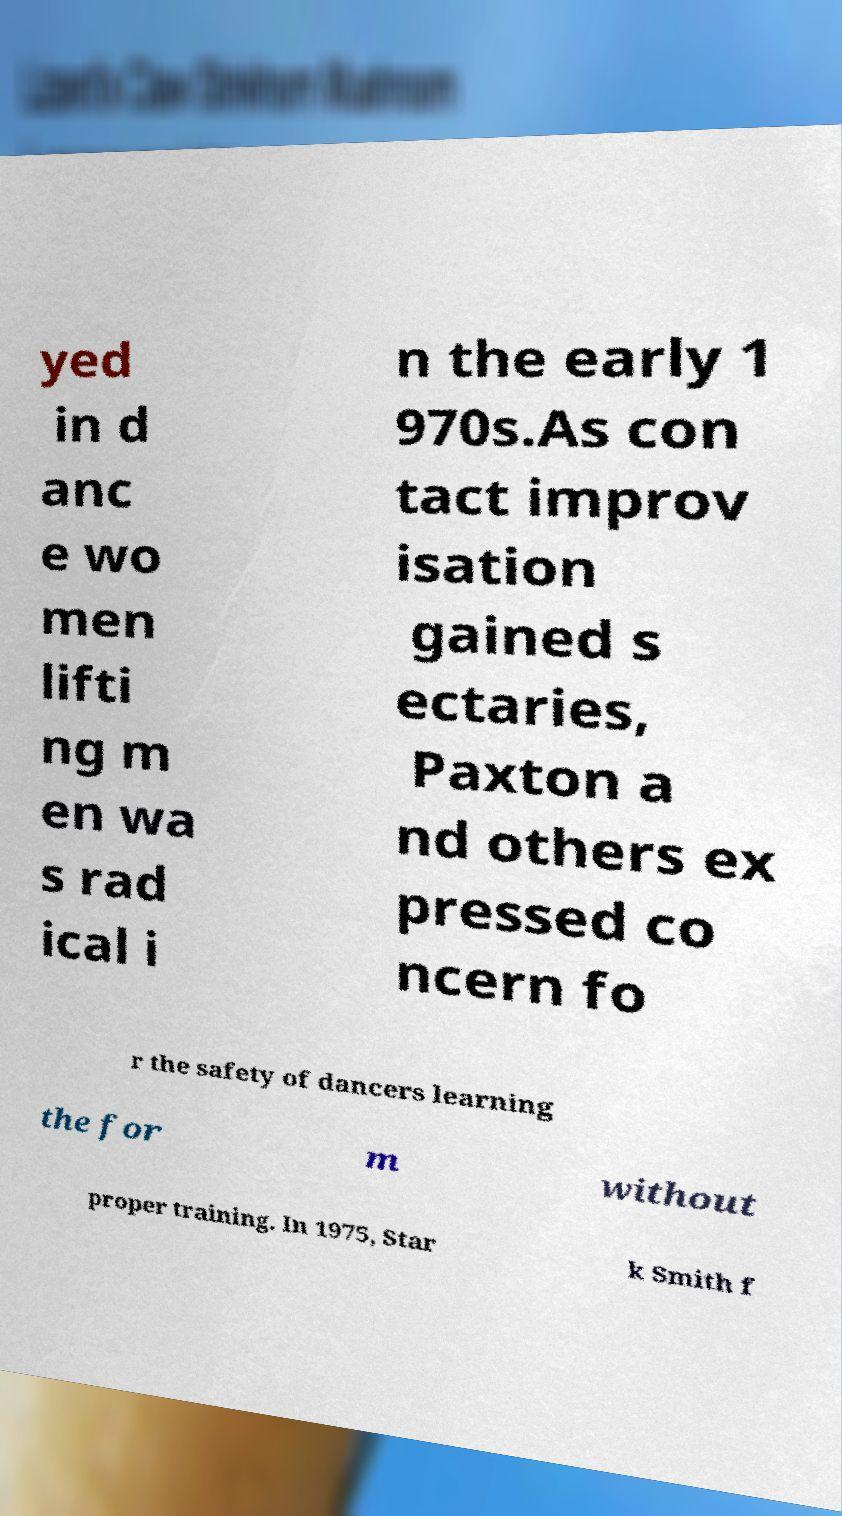Please identify and transcribe the text found in this image. yed in d anc e wo men lifti ng m en wa s rad ical i n the early 1 970s.As con tact improv isation gained s ectaries, Paxton a nd others ex pressed co ncern fo r the safety of dancers learning the for m without proper training. In 1975, Star k Smith f 